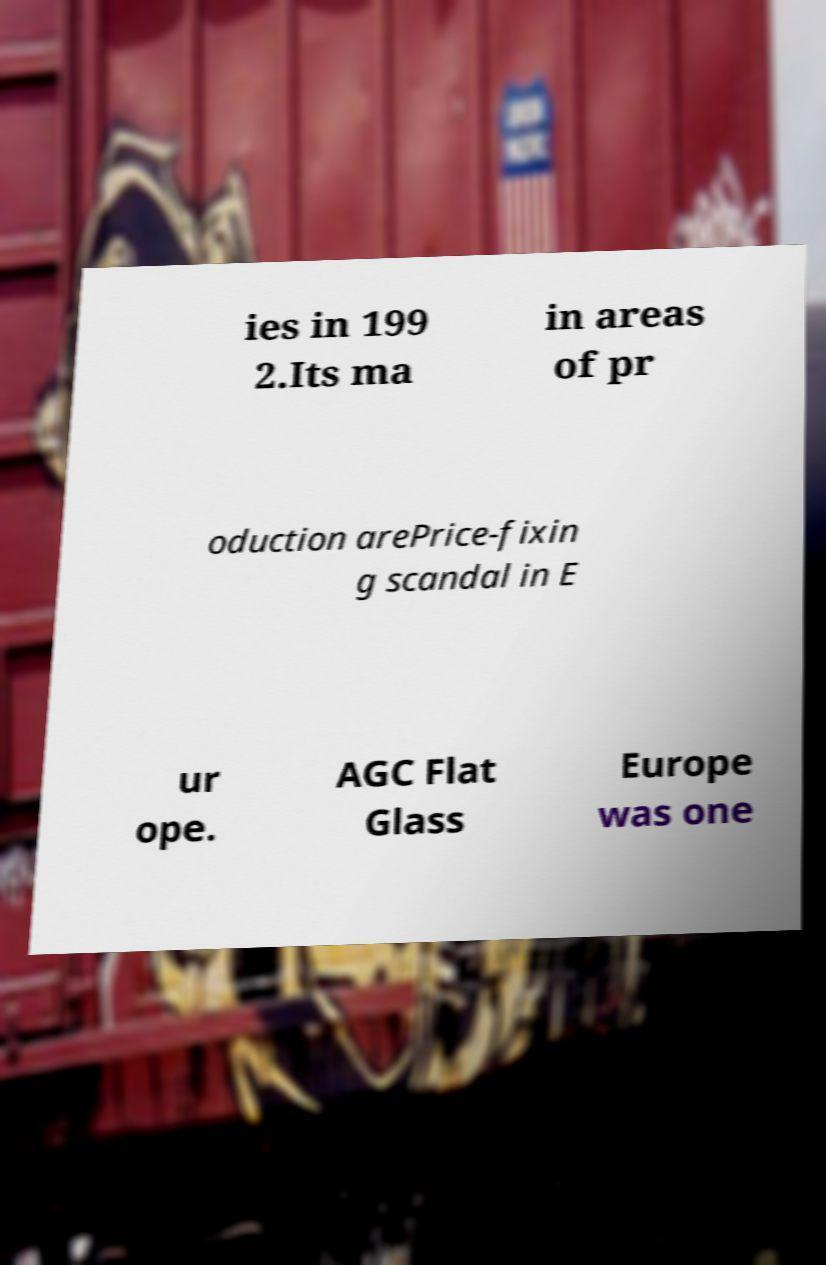There's text embedded in this image that I need extracted. Can you transcribe it verbatim? ies in 199 2.Its ma in areas of pr oduction arePrice-fixin g scandal in E ur ope. AGC Flat Glass Europe was one 